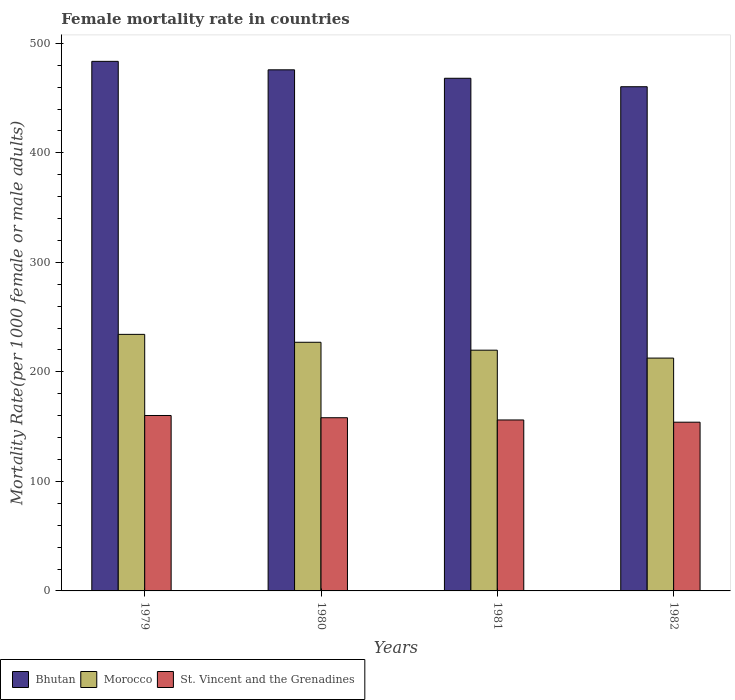How many different coloured bars are there?
Keep it short and to the point. 3. How many bars are there on the 3rd tick from the left?
Give a very brief answer. 3. How many bars are there on the 3rd tick from the right?
Your answer should be very brief. 3. What is the label of the 3rd group of bars from the left?
Offer a terse response. 1981. What is the female mortality rate in Morocco in 1982?
Give a very brief answer. 212.62. Across all years, what is the maximum female mortality rate in Bhutan?
Your answer should be compact. 483.58. Across all years, what is the minimum female mortality rate in St. Vincent and the Grenadines?
Give a very brief answer. 154.07. In which year was the female mortality rate in St. Vincent and the Grenadines maximum?
Ensure brevity in your answer.  1979. What is the total female mortality rate in Morocco in the graph?
Offer a very short reply. 893.79. What is the difference between the female mortality rate in Bhutan in 1981 and that in 1982?
Provide a short and direct response. 7.72. What is the difference between the female mortality rate in St. Vincent and the Grenadines in 1979 and the female mortality rate in Bhutan in 1980?
Offer a very short reply. -315.66. What is the average female mortality rate in Bhutan per year?
Your answer should be compact. 471.99. In the year 1980, what is the difference between the female mortality rate in Morocco and female mortality rate in Bhutan?
Give a very brief answer. -248.79. In how many years, is the female mortality rate in Bhutan greater than 420?
Your response must be concise. 4. What is the ratio of the female mortality rate in St. Vincent and the Grenadines in 1979 to that in 1981?
Offer a very short reply. 1.03. Is the female mortality rate in Bhutan in 1981 less than that in 1982?
Your answer should be very brief. No. What is the difference between the highest and the second highest female mortality rate in St. Vincent and the Grenadines?
Provide a short and direct response. 2.04. What is the difference between the highest and the lowest female mortality rate in Bhutan?
Offer a terse response. 23.18. What does the 2nd bar from the left in 1979 represents?
Provide a short and direct response. Morocco. What does the 3rd bar from the right in 1980 represents?
Provide a short and direct response. Bhutan. How many bars are there?
Keep it short and to the point. 12. Are all the bars in the graph horizontal?
Provide a short and direct response. No. How many years are there in the graph?
Provide a succinct answer. 4. Are the values on the major ticks of Y-axis written in scientific E-notation?
Ensure brevity in your answer.  No. Does the graph contain grids?
Give a very brief answer. No. How many legend labels are there?
Your answer should be compact. 3. How are the legend labels stacked?
Your response must be concise. Horizontal. What is the title of the graph?
Your response must be concise. Female mortality rate in countries. What is the label or title of the Y-axis?
Your answer should be very brief. Mortality Rate(per 1000 female or male adults). What is the Mortality Rate(per 1000 female or male adults) in Bhutan in 1979?
Make the answer very short. 483.58. What is the Mortality Rate(per 1000 female or male adults) of Morocco in 1979?
Your answer should be very brief. 234.28. What is the Mortality Rate(per 1000 female or male adults) of St. Vincent and the Grenadines in 1979?
Offer a very short reply. 160.19. What is the Mortality Rate(per 1000 female or male adults) of Bhutan in 1980?
Ensure brevity in your answer.  475.85. What is the Mortality Rate(per 1000 female or male adults) in Morocco in 1980?
Provide a short and direct response. 227.06. What is the Mortality Rate(per 1000 female or male adults) of St. Vincent and the Grenadines in 1980?
Keep it short and to the point. 158.15. What is the Mortality Rate(per 1000 female or male adults) of Bhutan in 1981?
Keep it short and to the point. 468.13. What is the Mortality Rate(per 1000 female or male adults) in Morocco in 1981?
Keep it short and to the point. 219.84. What is the Mortality Rate(per 1000 female or male adults) in St. Vincent and the Grenadines in 1981?
Offer a terse response. 156.11. What is the Mortality Rate(per 1000 female or male adults) of Bhutan in 1982?
Provide a short and direct response. 460.4. What is the Mortality Rate(per 1000 female or male adults) of Morocco in 1982?
Make the answer very short. 212.62. What is the Mortality Rate(per 1000 female or male adults) of St. Vincent and the Grenadines in 1982?
Make the answer very short. 154.07. Across all years, what is the maximum Mortality Rate(per 1000 female or male adults) of Bhutan?
Ensure brevity in your answer.  483.58. Across all years, what is the maximum Mortality Rate(per 1000 female or male adults) of Morocco?
Give a very brief answer. 234.28. Across all years, what is the maximum Mortality Rate(per 1000 female or male adults) in St. Vincent and the Grenadines?
Give a very brief answer. 160.19. Across all years, what is the minimum Mortality Rate(per 1000 female or male adults) of Bhutan?
Provide a short and direct response. 460.4. Across all years, what is the minimum Mortality Rate(per 1000 female or male adults) of Morocco?
Your response must be concise. 212.62. Across all years, what is the minimum Mortality Rate(per 1000 female or male adults) of St. Vincent and the Grenadines?
Your answer should be compact. 154.07. What is the total Mortality Rate(per 1000 female or male adults) in Bhutan in the graph?
Ensure brevity in your answer.  1887.95. What is the total Mortality Rate(per 1000 female or male adults) of Morocco in the graph?
Provide a short and direct response. 893.79. What is the total Mortality Rate(per 1000 female or male adults) of St. Vincent and the Grenadines in the graph?
Make the answer very short. 628.51. What is the difference between the Mortality Rate(per 1000 female or male adults) of Bhutan in 1979 and that in 1980?
Offer a terse response. 7.73. What is the difference between the Mortality Rate(per 1000 female or male adults) of Morocco in 1979 and that in 1980?
Provide a short and direct response. 7.22. What is the difference between the Mortality Rate(per 1000 female or male adults) in St. Vincent and the Grenadines in 1979 and that in 1980?
Ensure brevity in your answer.  2.04. What is the difference between the Mortality Rate(per 1000 female or male adults) of Bhutan in 1979 and that in 1981?
Make the answer very short. 15.45. What is the difference between the Mortality Rate(per 1000 female or male adults) in Morocco in 1979 and that in 1981?
Offer a very short reply. 14.44. What is the difference between the Mortality Rate(per 1000 female or male adults) in St. Vincent and the Grenadines in 1979 and that in 1981?
Your answer should be very brief. 4.08. What is the difference between the Mortality Rate(per 1000 female or male adults) of Bhutan in 1979 and that in 1982?
Make the answer very short. 23.18. What is the difference between the Mortality Rate(per 1000 female or male adults) of Morocco in 1979 and that in 1982?
Offer a terse response. 21.66. What is the difference between the Mortality Rate(per 1000 female or male adults) of St. Vincent and the Grenadines in 1979 and that in 1982?
Your answer should be compact. 6.12. What is the difference between the Mortality Rate(per 1000 female or male adults) of Bhutan in 1980 and that in 1981?
Keep it short and to the point. 7.72. What is the difference between the Mortality Rate(per 1000 female or male adults) in Morocco in 1980 and that in 1981?
Offer a very short reply. 7.22. What is the difference between the Mortality Rate(per 1000 female or male adults) in St. Vincent and the Grenadines in 1980 and that in 1981?
Your answer should be very brief. 2.04. What is the difference between the Mortality Rate(per 1000 female or male adults) in Bhutan in 1980 and that in 1982?
Offer a very short reply. 15.45. What is the difference between the Mortality Rate(per 1000 female or male adults) in Morocco in 1980 and that in 1982?
Your response must be concise. 14.44. What is the difference between the Mortality Rate(per 1000 female or male adults) in St. Vincent and the Grenadines in 1980 and that in 1982?
Your response must be concise. 4.08. What is the difference between the Mortality Rate(per 1000 female or male adults) of Bhutan in 1981 and that in 1982?
Make the answer very short. 7.72. What is the difference between the Mortality Rate(per 1000 female or male adults) in Morocco in 1981 and that in 1982?
Your answer should be compact. 7.22. What is the difference between the Mortality Rate(per 1000 female or male adults) of St. Vincent and the Grenadines in 1981 and that in 1982?
Give a very brief answer. 2.04. What is the difference between the Mortality Rate(per 1000 female or male adults) in Bhutan in 1979 and the Mortality Rate(per 1000 female or male adults) in Morocco in 1980?
Give a very brief answer. 256.52. What is the difference between the Mortality Rate(per 1000 female or male adults) in Bhutan in 1979 and the Mortality Rate(per 1000 female or male adults) in St. Vincent and the Grenadines in 1980?
Provide a short and direct response. 325.43. What is the difference between the Mortality Rate(per 1000 female or male adults) in Morocco in 1979 and the Mortality Rate(per 1000 female or male adults) in St. Vincent and the Grenadines in 1980?
Ensure brevity in your answer.  76.13. What is the difference between the Mortality Rate(per 1000 female or male adults) in Bhutan in 1979 and the Mortality Rate(per 1000 female or male adults) in Morocco in 1981?
Make the answer very short. 263.74. What is the difference between the Mortality Rate(per 1000 female or male adults) in Bhutan in 1979 and the Mortality Rate(per 1000 female or male adults) in St. Vincent and the Grenadines in 1981?
Your answer should be compact. 327.47. What is the difference between the Mortality Rate(per 1000 female or male adults) in Morocco in 1979 and the Mortality Rate(per 1000 female or male adults) in St. Vincent and the Grenadines in 1981?
Offer a terse response. 78.17. What is the difference between the Mortality Rate(per 1000 female or male adults) of Bhutan in 1979 and the Mortality Rate(per 1000 female or male adults) of Morocco in 1982?
Make the answer very short. 270.96. What is the difference between the Mortality Rate(per 1000 female or male adults) of Bhutan in 1979 and the Mortality Rate(per 1000 female or male adults) of St. Vincent and the Grenadines in 1982?
Ensure brevity in your answer.  329.51. What is the difference between the Mortality Rate(per 1000 female or male adults) in Morocco in 1979 and the Mortality Rate(per 1000 female or male adults) in St. Vincent and the Grenadines in 1982?
Ensure brevity in your answer.  80.21. What is the difference between the Mortality Rate(per 1000 female or male adults) of Bhutan in 1980 and the Mortality Rate(per 1000 female or male adults) of Morocco in 1981?
Offer a terse response. 256.01. What is the difference between the Mortality Rate(per 1000 female or male adults) in Bhutan in 1980 and the Mortality Rate(per 1000 female or male adults) in St. Vincent and the Grenadines in 1981?
Your response must be concise. 319.74. What is the difference between the Mortality Rate(per 1000 female or male adults) of Morocco in 1980 and the Mortality Rate(per 1000 female or male adults) of St. Vincent and the Grenadines in 1981?
Your answer should be compact. 70.95. What is the difference between the Mortality Rate(per 1000 female or male adults) in Bhutan in 1980 and the Mortality Rate(per 1000 female or male adults) in Morocco in 1982?
Provide a succinct answer. 263.23. What is the difference between the Mortality Rate(per 1000 female or male adults) of Bhutan in 1980 and the Mortality Rate(per 1000 female or male adults) of St. Vincent and the Grenadines in 1982?
Ensure brevity in your answer.  321.78. What is the difference between the Mortality Rate(per 1000 female or male adults) in Morocco in 1980 and the Mortality Rate(per 1000 female or male adults) in St. Vincent and the Grenadines in 1982?
Keep it short and to the point. 72.99. What is the difference between the Mortality Rate(per 1000 female or male adults) in Bhutan in 1981 and the Mortality Rate(per 1000 female or male adults) in Morocco in 1982?
Give a very brief answer. 255.51. What is the difference between the Mortality Rate(per 1000 female or male adults) of Bhutan in 1981 and the Mortality Rate(per 1000 female or male adults) of St. Vincent and the Grenadines in 1982?
Your response must be concise. 314.06. What is the difference between the Mortality Rate(per 1000 female or male adults) in Morocco in 1981 and the Mortality Rate(per 1000 female or male adults) in St. Vincent and the Grenadines in 1982?
Offer a very short reply. 65.77. What is the average Mortality Rate(per 1000 female or male adults) in Bhutan per year?
Keep it short and to the point. 471.99. What is the average Mortality Rate(per 1000 female or male adults) in Morocco per year?
Keep it short and to the point. 223.45. What is the average Mortality Rate(per 1000 female or male adults) in St. Vincent and the Grenadines per year?
Ensure brevity in your answer.  157.13. In the year 1979, what is the difference between the Mortality Rate(per 1000 female or male adults) in Bhutan and Mortality Rate(per 1000 female or male adults) in Morocco?
Your response must be concise. 249.3. In the year 1979, what is the difference between the Mortality Rate(per 1000 female or male adults) in Bhutan and Mortality Rate(per 1000 female or male adults) in St. Vincent and the Grenadines?
Give a very brief answer. 323.39. In the year 1979, what is the difference between the Mortality Rate(per 1000 female or male adults) of Morocco and Mortality Rate(per 1000 female or male adults) of St. Vincent and the Grenadines?
Provide a succinct answer. 74.09. In the year 1980, what is the difference between the Mortality Rate(per 1000 female or male adults) in Bhutan and Mortality Rate(per 1000 female or male adults) in Morocco?
Your answer should be compact. 248.79. In the year 1980, what is the difference between the Mortality Rate(per 1000 female or male adults) of Bhutan and Mortality Rate(per 1000 female or male adults) of St. Vincent and the Grenadines?
Your response must be concise. 317.7. In the year 1980, what is the difference between the Mortality Rate(per 1000 female or male adults) of Morocco and Mortality Rate(per 1000 female or male adults) of St. Vincent and the Grenadines?
Your response must be concise. 68.91. In the year 1981, what is the difference between the Mortality Rate(per 1000 female or male adults) of Bhutan and Mortality Rate(per 1000 female or male adults) of Morocco?
Provide a short and direct response. 248.29. In the year 1981, what is the difference between the Mortality Rate(per 1000 female or male adults) of Bhutan and Mortality Rate(per 1000 female or male adults) of St. Vincent and the Grenadines?
Make the answer very short. 312.02. In the year 1981, what is the difference between the Mortality Rate(per 1000 female or male adults) in Morocco and Mortality Rate(per 1000 female or male adults) in St. Vincent and the Grenadines?
Offer a very short reply. 63.73. In the year 1982, what is the difference between the Mortality Rate(per 1000 female or male adults) of Bhutan and Mortality Rate(per 1000 female or male adults) of Morocco?
Offer a terse response. 247.78. In the year 1982, what is the difference between the Mortality Rate(per 1000 female or male adults) in Bhutan and Mortality Rate(per 1000 female or male adults) in St. Vincent and the Grenadines?
Ensure brevity in your answer.  306.33. In the year 1982, what is the difference between the Mortality Rate(per 1000 female or male adults) in Morocco and Mortality Rate(per 1000 female or male adults) in St. Vincent and the Grenadines?
Your answer should be compact. 58.55. What is the ratio of the Mortality Rate(per 1000 female or male adults) in Bhutan in 1979 to that in 1980?
Offer a very short reply. 1.02. What is the ratio of the Mortality Rate(per 1000 female or male adults) in Morocco in 1979 to that in 1980?
Your answer should be very brief. 1.03. What is the ratio of the Mortality Rate(per 1000 female or male adults) in St. Vincent and the Grenadines in 1979 to that in 1980?
Your response must be concise. 1.01. What is the ratio of the Mortality Rate(per 1000 female or male adults) of Bhutan in 1979 to that in 1981?
Your answer should be compact. 1.03. What is the ratio of the Mortality Rate(per 1000 female or male adults) of Morocco in 1979 to that in 1981?
Ensure brevity in your answer.  1.07. What is the ratio of the Mortality Rate(per 1000 female or male adults) of St. Vincent and the Grenadines in 1979 to that in 1981?
Offer a terse response. 1.03. What is the ratio of the Mortality Rate(per 1000 female or male adults) in Bhutan in 1979 to that in 1982?
Make the answer very short. 1.05. What is the ratio of the Mortality Rate(per 1000 female or male adults) in Morocco in 1979 to that in 1982?
Offer a very short reply. 1.1. What is the ratio of the Mortality Rate(per 1000 female or male adults) in St. Vincent and the Grenadines in 1979 to that in 1982?
Offer a very short reply. 1.04. What is the ratio of the Mortality Rate(per 1000 female or male adults) of Bhutan in 1980 to that in 1981?
Your answer should be very brief. 1.02. What is the ratio of the Mortality Rate(per 1000 female or male adults) in Morocco in 1980 to that in 1981?
Ensure brevity in your answer.  1.03. What is the ratio of the Mortality Rate(per 1000 female or male adults) of St. Vincent and the Grenadines in 1980 to that in 1981?
Your response must be concise. 1.01. What is the ratio of the Mortality Rate(per 1000 female or male adults) of Bhutan in 1980 to that in 1982?
Your answer should be very brief. 1.03. What is the ratio of the Mortality Rate(per 1000 female or male adults) in Morocco in 1980 to that in 1982?
Keep it short and to the point. 1.07. What is the ratio of the Mortality Rate(per 1000 female or male adults) in St. Vincent and the Grenadines in 1980 to that in 1982?
Keep it short and to the point. 1.03. What is the ratio of the Mortality Rate(per 1000 female or male adults) of Bhutan in 1981 to that in 1982?
Provide a succinct answer. 1.02. What is the ratio of the Mortality Rate(per 1000 female or male adults) in Morocco in 1981 to that in 1982?
Provide a short and direct response. 1.03. What is the ratio of the Mortality Rate(per 1000 female or male adults) of St. Vincent and the Grenadines in 1981 to that in 1982?
Your answer should be compact. 1.01. What is the difference between the highest and the second highest Mortality Rate(per 1000 female or male adults) of Bhutan?
Provide a succinct answer. 7.73. What is the difference between the highest and the second highest Mortality Rate(per 1000 female or male adults) of Morocco?
Give a very brief answer. 7.22. What is the difference between the highest and the second highest Mortality Rate(per 1000 female or male adults) in St. Vincent and the Grenadines?
Give a very brief answer. 2.04. What is the difference between the highest and the lowest Mortality Rate(per 1000 female or male adults) of Bhutan?
Offer a very short reply. 23.18. What is the difference between the highest and the lowest Mortality Rate(per 1000 female or male adults) of Morocco?
Provide a succinct answer. 21.66. What is the difference between the highest and the lowest Mortality Rate(per 1000 female or male adults) of St. Vincent and the Grenadines?
Provide a short and direct response. 6.12. 